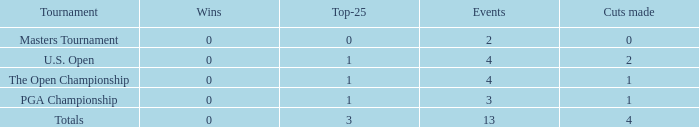How many cuts did he make in the tournament with 3 top 25s and under 13 events? None. 